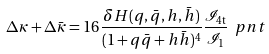<formula> <loc_0><loc_0><loc_500><loc_500>\Delta \kappa + \Delta \bar { \kappa } = 1 6 \frac { \delta H ( q , \bar { q } , h , \bar { h } ) } { ( 1 + q \bar { q } + h \bar { h } ) ^ { 4 } } \frac { \mathcal { I } _ { 4 \text {t} } } { \mathcal { I } _ { 1 } } \ p n t</formula> 